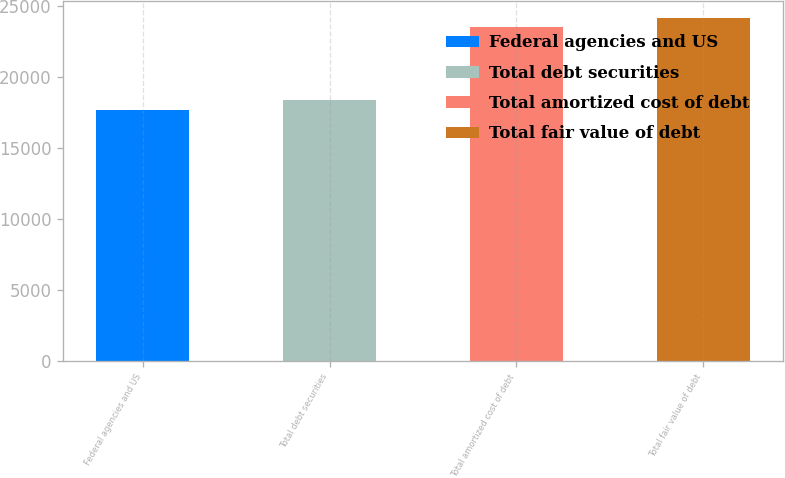Convert chart. <chart><loc_0><loc_0><loc_500><loc_500><bar_chart><fcel>Federal agencies and US<fcel>Total debt securities<fcel>Total amortized cost of debt<fcel>Total fair value of debt<nl><fcel>17683<fcel>18411<fcel>23559<fcel>24173.1<nl></chart> 